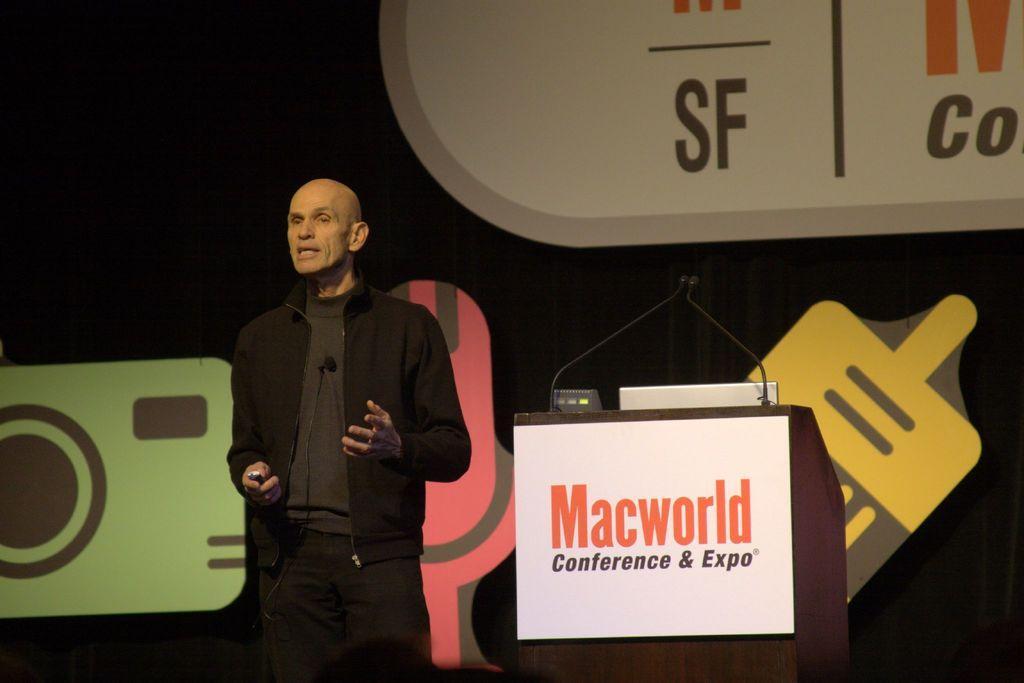Describe this image in one or two sentences. In this image we can see this person wearing black jacket is holding some object and standing here. Here we can see the podium to which a white color board is fixed and here we can see the laptop and mics are placed on it. The background of the image is dark where we can see some images. 